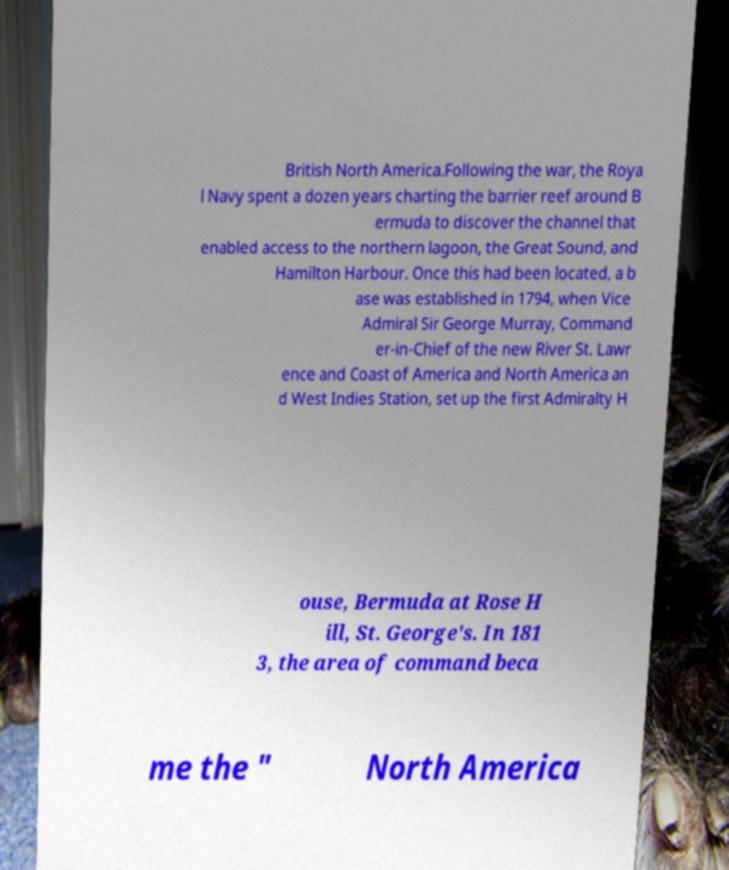Can you accurately transcribe the text from the provided image for me? British North America.Following the war, the Roya l Navy spent a dozen years charting the barrier reef around B ermuda to discover the channel that enabled access to the northern lagoon, the Great Sound, and Hamilton Harbour. Once this had been located, a b ase was established in 1794, when Vice Admiral Sir George Murray, Command er-in-Chief of the new River St. Lawr ence and Coast of America and North America an d West Indies Station, set up the first Admiralty H ouse, Bermuda at Rose H ill, St. George's. In 181 3, the area of command beca me the " North America 